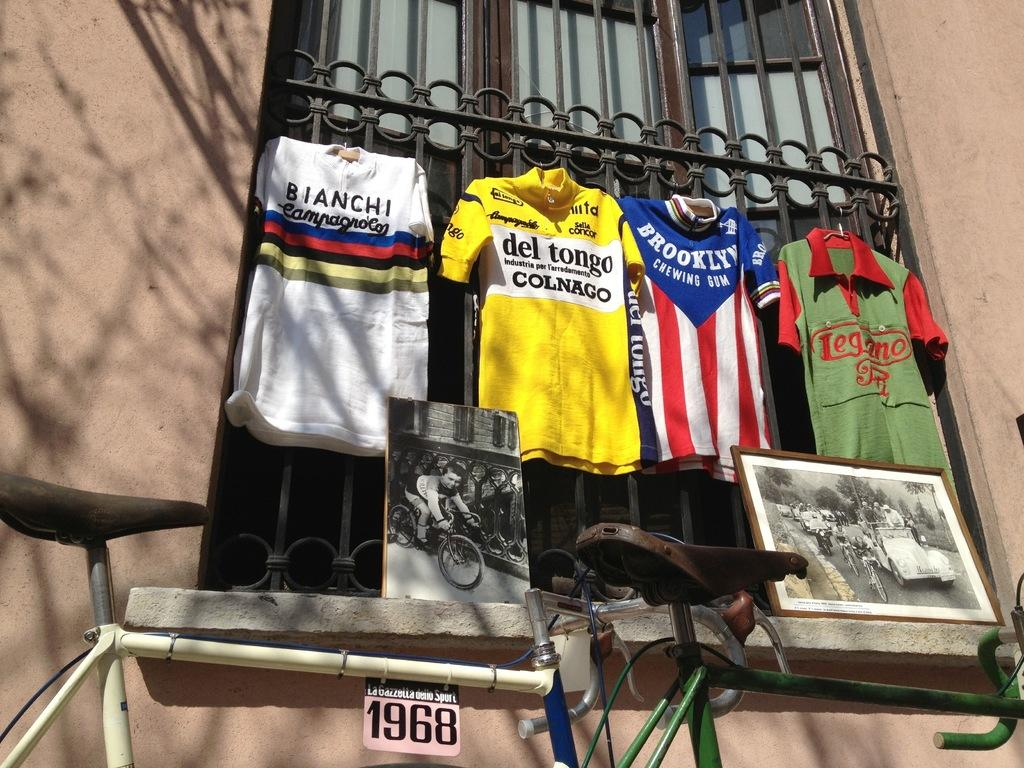Provide a one-sentence caption for the provided image. Four jerseys hanging out a window and one is bright yellow with Del tongo Colnago displayed on the front. 